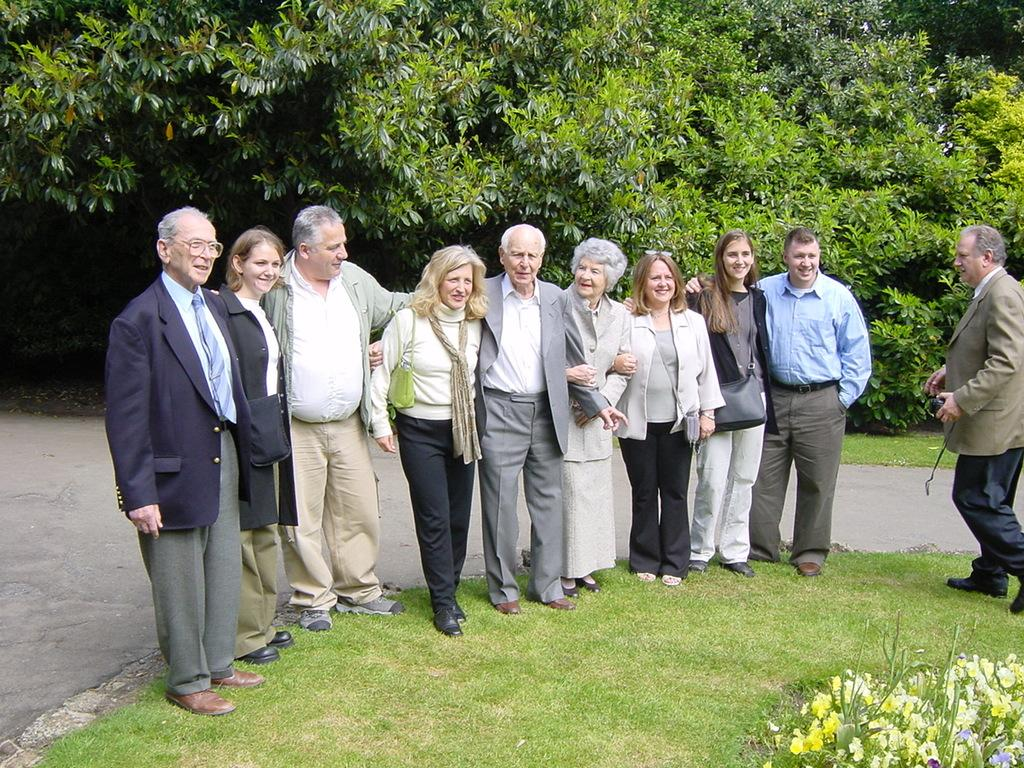What can be seen in the image? There are people standing in the image. What is on the ground in the image? There is grass on the ground in the image. Are there any plants visible in the image? Yes, there are flowering plants in the image. What can be seen in the distance in the image? There is a road and trees visible in the background of the image. What type of scent is emitted by the vessel in the image? There is no vessel present in the image, so it is not possible to determine the scent emitted by any vessel. 